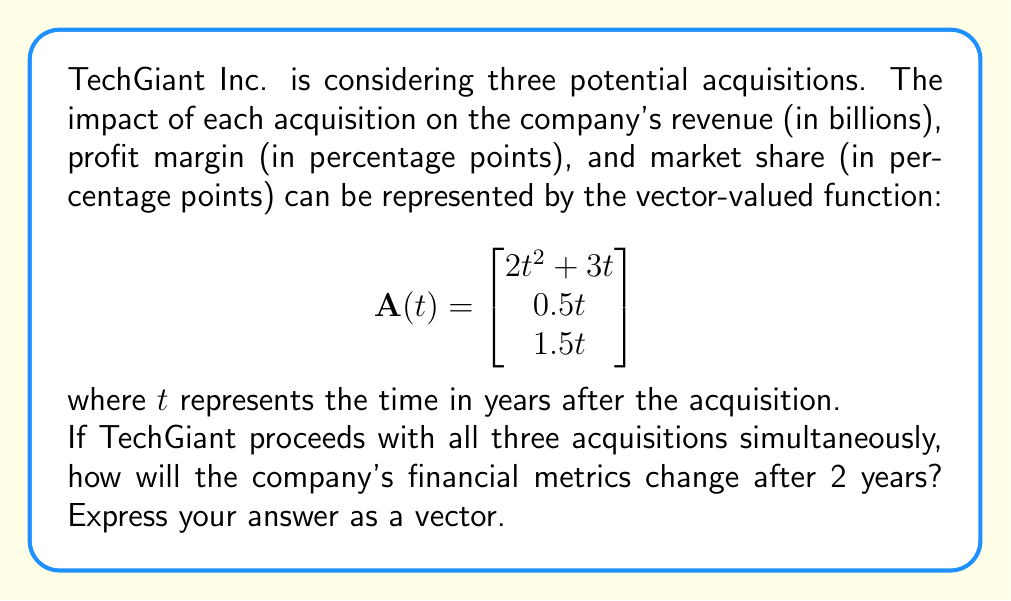Solve this math problem. To solve this problem, we need to follow these steps:

1) The given vector-valued function $\mathbf{A}(t)$ represents the impact of a single acquisition. Since TechGiant is considering three acquisitions, we need to multiply the function by 3.

2) We need to evaluate the function at $t = 2$ years.

3) Let's calculate each component of the vector:

   For revenue:
   $3(2t^2 + 3t)|_{t=2} = 3(2(2)^2 + 3(2)) = 3(8 + 6) = 3(14) = 42$

   For profit margin:
   $3(0.5t)|_{t=2} = 3(0.5(2)) = 3(1) = 3$

   For market share:
   $3(1.5t)|_{t=2} = 3(1.5(2)) = 3(3) = 9$

4) Therefore, after 2 years, the impact of the three acquisitions can be represented by the vector:

   $$\mathbf{A}(2) = \begin{bmatrix}
   42 \\
   3 \\
   9
   \end{bmatrix}$$

This means that after 2 years:
- Revenue will increase by 42 billion dollars
- Profit margin will increase by 3 percentage points
- Market share will increase by 9 percentage points
Answer: $$\begin{bmatrix}
42 \\
3 \\
9
\end{bmatrix}$$ 